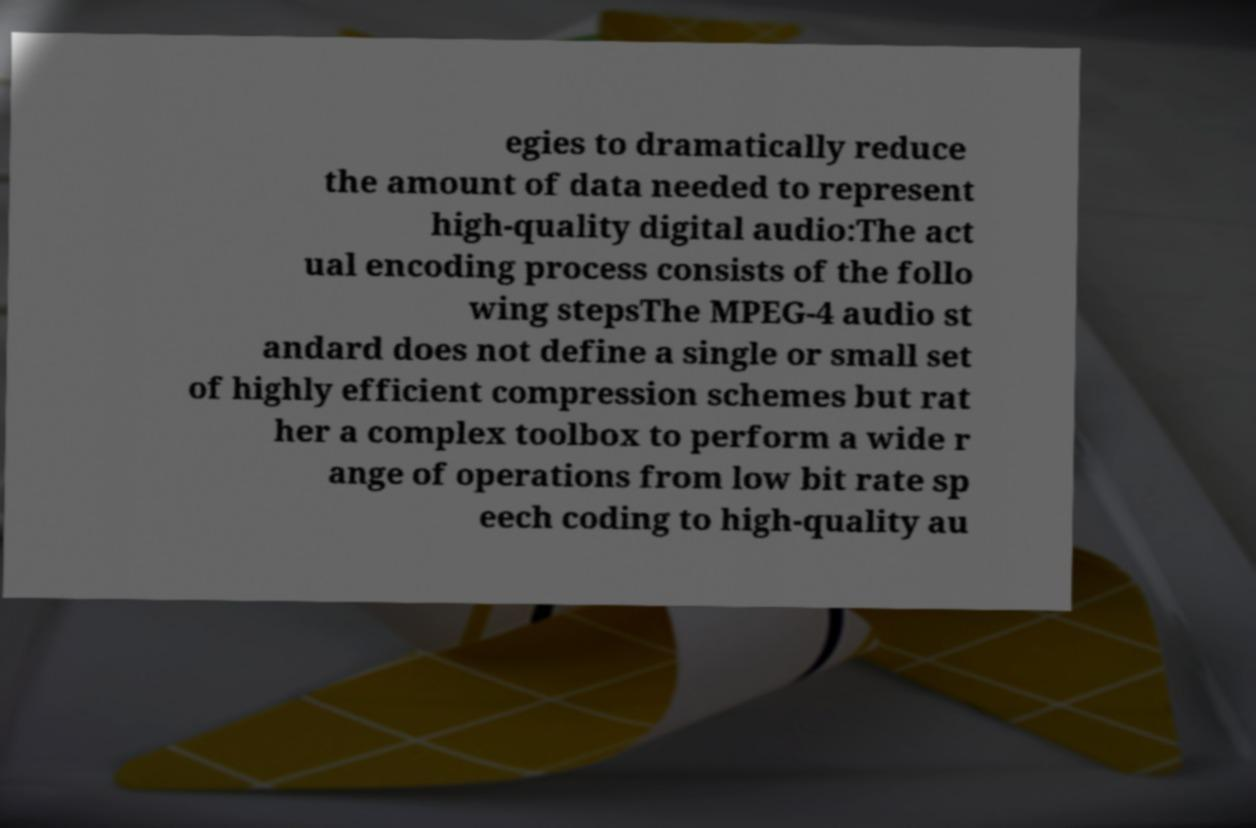What messages or text are displayed in this image? I need them in a readable, typed format. egies to dramatically reduce the amount of data needed to represent high-quality digital audio:The act ual encoding process consists of the follo wing stepsThe MPEG-4 audio st andard does not define a single or small set of highly efficient compression schemes but rat her a complex toolbox to perform a wide r ange of operations from low bit rate sp eech coding to high-quality au 